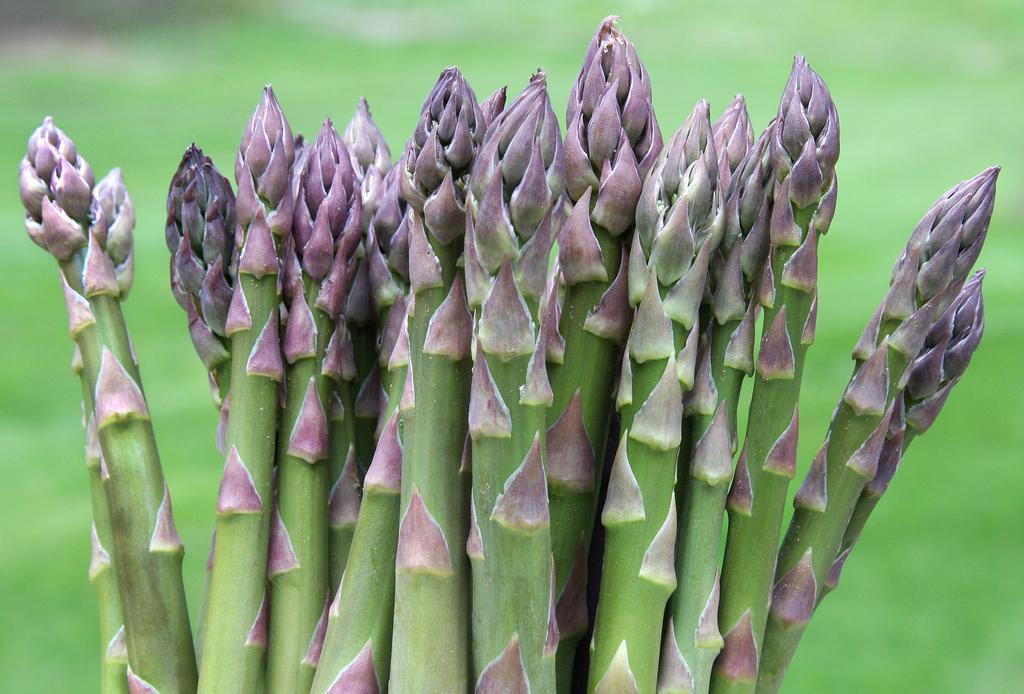What is the main subject of the image? The main subject of the image is some buds. How are the buds captured in the image? The image contains macro photography of the buds. What can be observed about the background of the image? The background of the image is blurred. What type of polish is being applied to the buds in the image? There is no polish being applied to the buds in the image; it is a photograph of the buds themselves. 